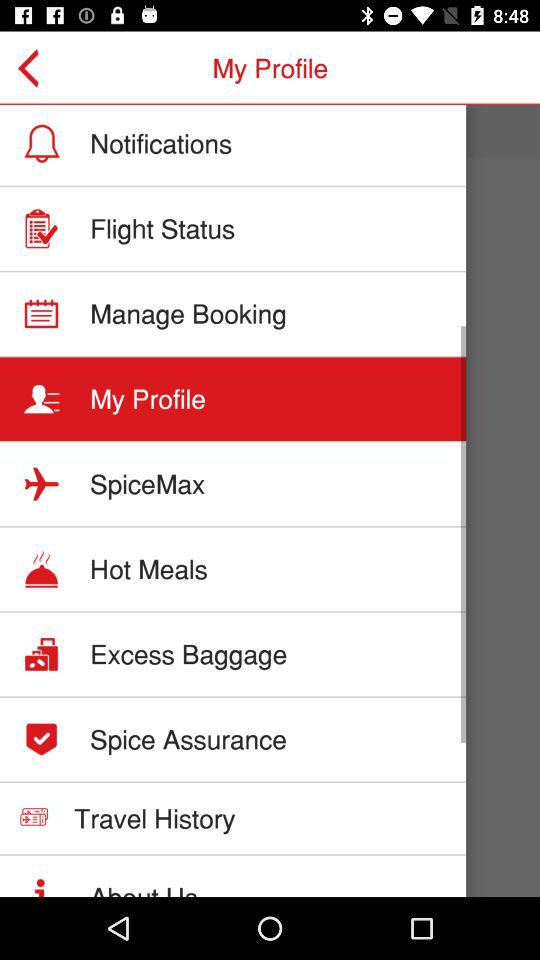Which option is selected? The selected option is "My Profile". 